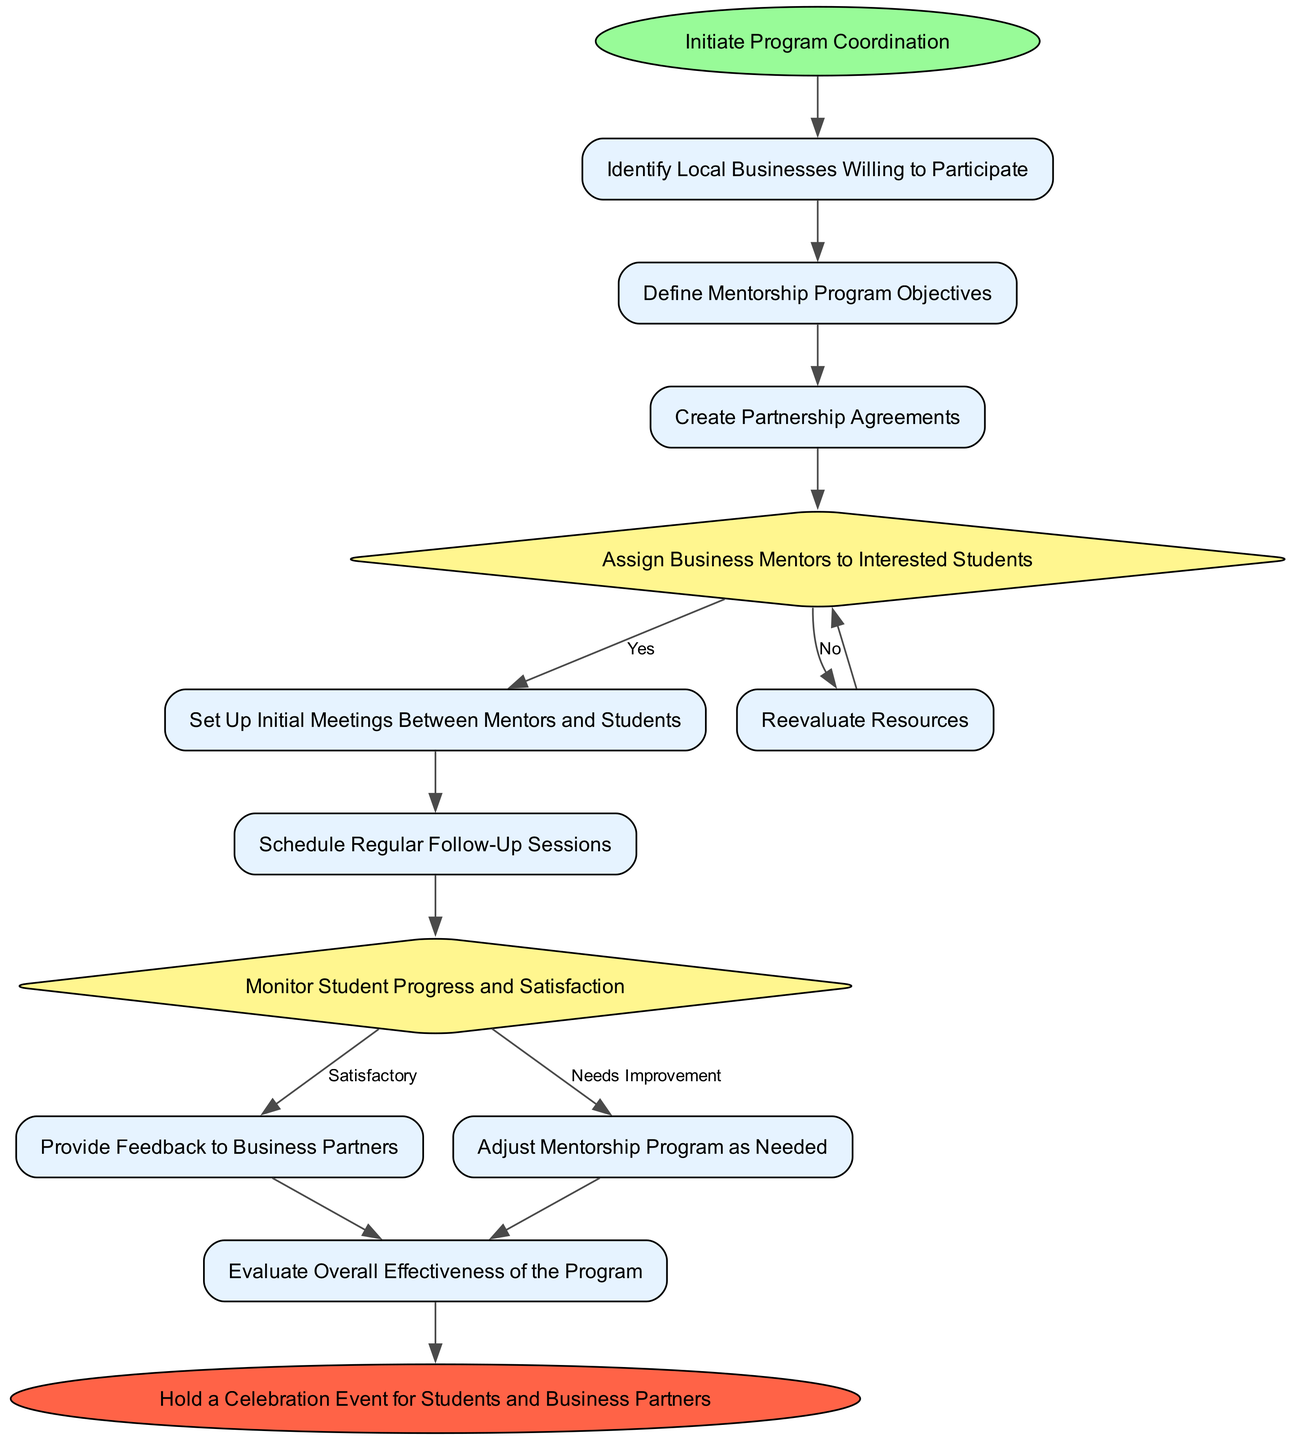What is the first step in the coordination process? The first step is marked by the start node, which says "Initiate Program Coordination." Therefore, this node indicates what must be done first in the flow of the program.
Answer: Initiate Program Coordination How many decision nodes are present in the flowchart? By reviewing the diagram, we can count the decision nodes. There are two decision nodes: "Assign Business Mentors to Interested Students" and "Monitor Student Progress and Satisfaction."
Answer: 2 What happens if the answer to "Assign Business Mentors to Interested Students" is 'No'? According to the diagram, if the answer to "Assign Business Mentors to Interested Students" is 'No', it leads to "Reevaluate Resources," which is the next step in that path.
Answer: Reevaluate Resources What is the last step before the celebration event? The last step before reaching the celebration event is "Evaluate Overall Effectiveness of the Program," which precedes the final event in the flowchart.
Answer: Evaluate Overall Effectiveness of the Program In the process, what follows "Set Up Initial Meetings Between Mentors and Students"? After the "Set Up Initial Meetings Between Mentors and Students" step, the next process is "Schedule Regular Follow-Up Sessions," indicating that follow-ups are needed after initial meetings.
Answer: Schedule Regular Follow-Up Sessions What must happen if the student progress is deemed 'Needs Improvement'? If student progress is labeled as 'Needs Improvement', the diagram indicates that the flow goes to "Adjust Mentorship Program as Needed" to make necessary changes to improve the program.
Answer: Adjust Mentorship Program as Needed Which node directly follows "Create Partnership Agreements"? The node that immediately follows "Create Partnership Agreements" is "Assign Business Mentors to Interested Students," signaling the continuation of the mentorship program steps.
Answer: Assign Business Mentors to Interested Students 